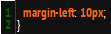Convert code to text. <code><loc_0><loc_0><loc_500><loc_500><_CSS_>  margin-left: 10px;
}
</code> 